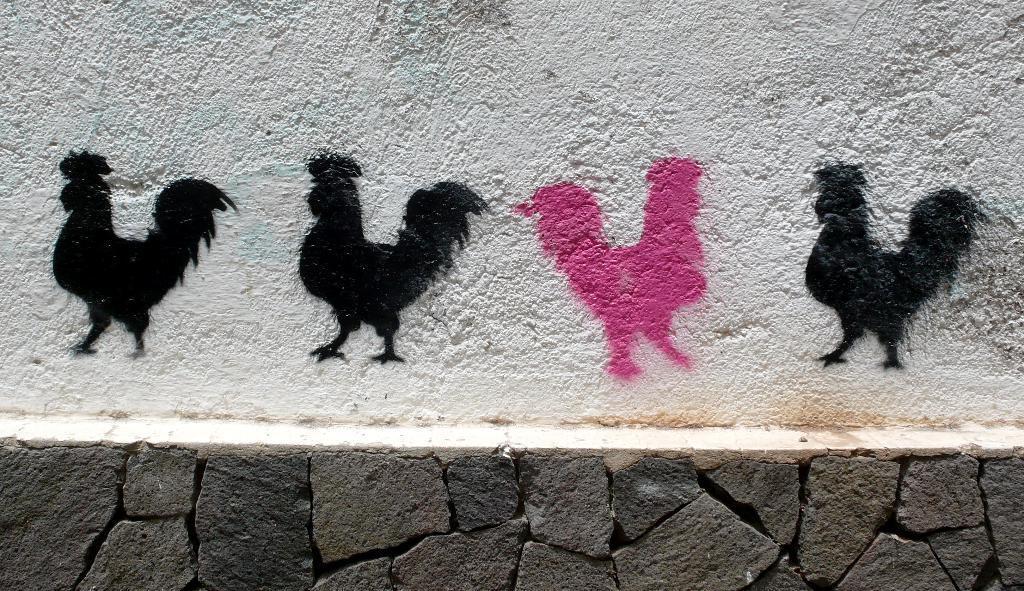In one or two sentences, can you explain what this image depicts? In the image we can see there are paintings of hen on the wall. There is a rock wall. 